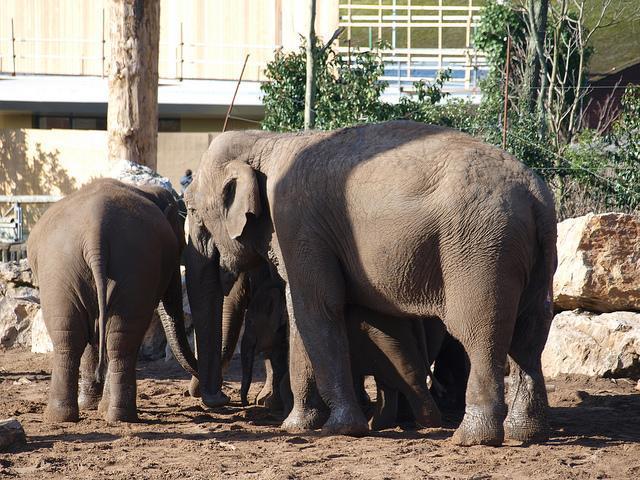How many elephants are visible?
Give a very brief answer. 4. 